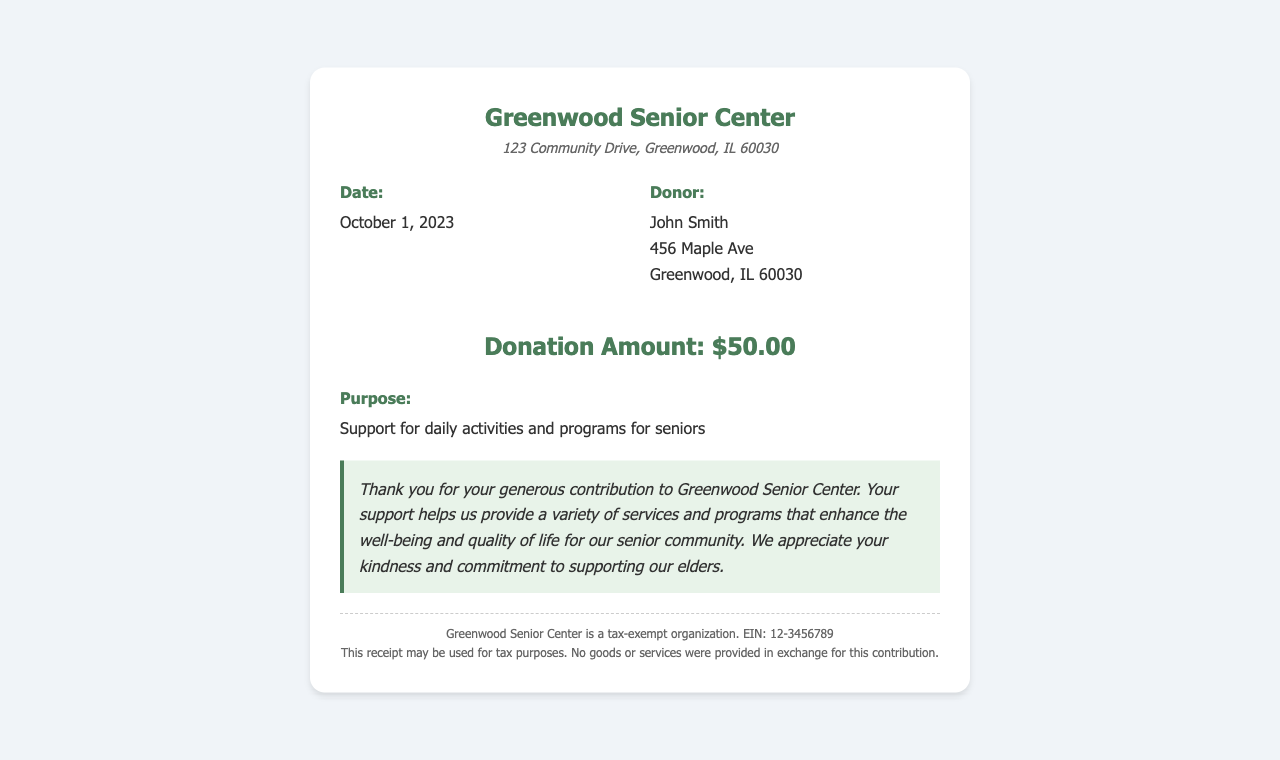what is the date of the donation? The date of the donation is specified in the document, listed under the date section.
Answer: October 1, 2023 who is the donor? The donor's name and address are provided in the donor section of the receipt.
Answer: John Smith what is the amount donated? The donation amount is highlighted in the document as a key figure.
Answer: $50.00 what is the purpose of the donation? The purpose of the donation is explicitly stated in the relevant section of the document.
Answer: Support for daily activities and programs for seniors what type of document is this? This document is specifically a receipt for a donation made to a senior center.
Answer: Donation receipt what is the address of the organization? The organization's address is provided in the header section of the receipt.
Answer: 123 Community Drive, Greenwood, IL 60030 what does the acknowledgment express? The acknowledgment section expresses gratitude for the donor's contribution.
Answer: Thank you for your generous contribution to Greenwood Senior Center is the Greenwood Senior Center a tax-exempt organization? The footer section of the document states the tax-exempt status of the organization.
Answer: Yes, it is a tax-exempt organization 